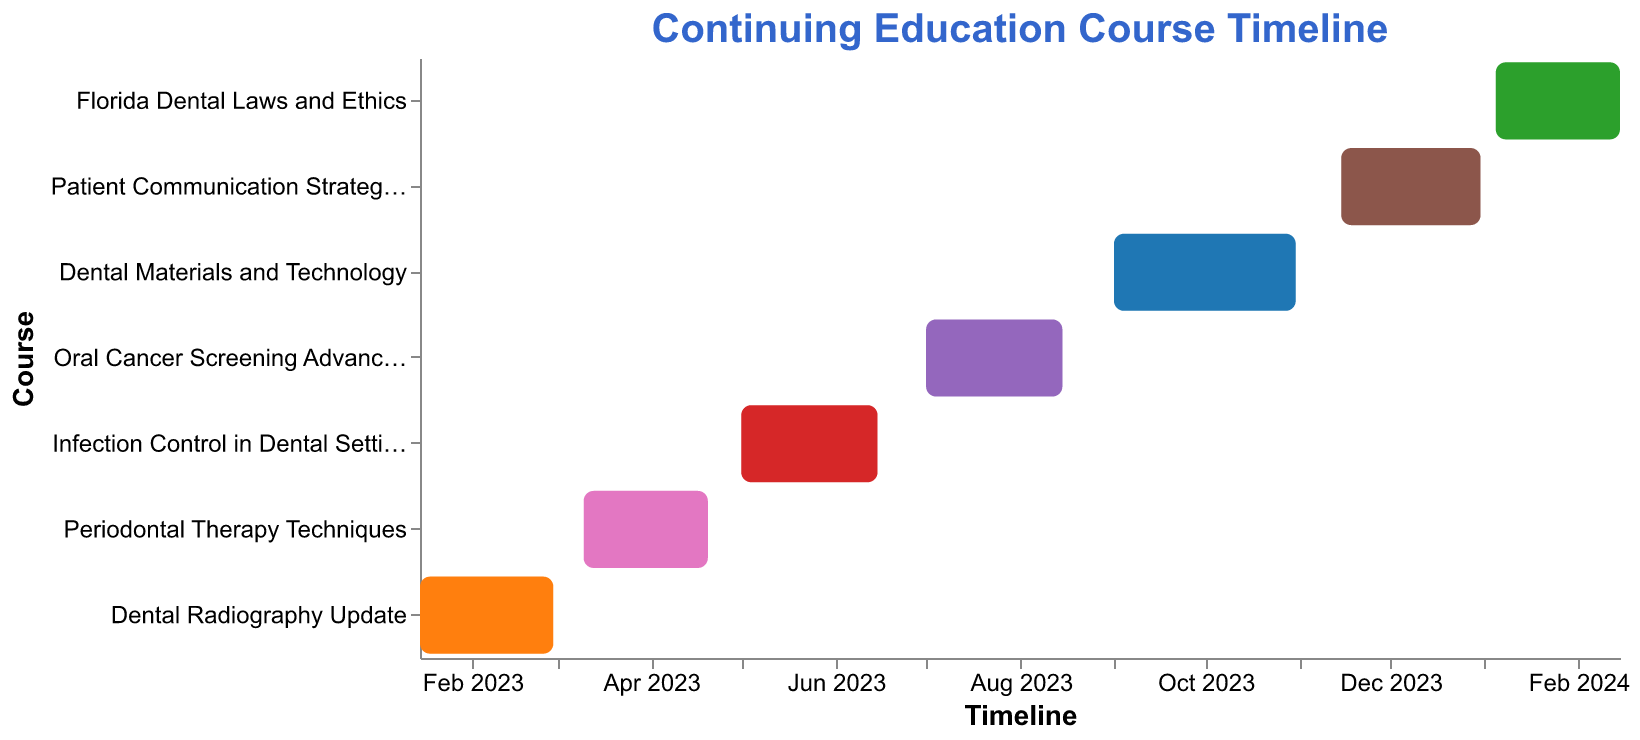How many courses are scheduled for 2023? Look at the timeline on the x-axis and count all the courses that start and end in 2023. There are six courses scheduled for 2023.
Answer: Six When does the "Oral Cancer Screening Advancements" course begin and end? Refer to the location of the bar representing the "Oral Cancer Screening Advancements" course on the Gantt chart to see its start and end dates. It starts on July 1, 2023, and ends on August 15, 2023.
Answer: Starts on July 1, 2023, and ends on August 15, 2023 Which course has the longest duration? Calculate the duration of each course by finding the differences between their start and end dates. The "Dental Materials and Technology" course runs for 61 days (from September 1, 2023, to October 31, 2023).
Answer: Dental Materials and Technology What is the gap between the end of the "Infection Control in Dental Settings" course and the start of the "Oral Cancer Screening Advancements" course? The "Infection Control in Dental Settings" ends on June 15, 2023, and the "Oral Cancer Screening Advancements" begins on July 1, 2023. The gap is 16 days.
Answer: 16 days Which courses run simultaneously for at least part of their duration? Examine the Gantt chart to see overlapping bars, indicating simultaneous courses. "Infection Control in Dental Settings" (May 1, 2023, to June 15, 2023) and "Periodontal Therapy Techniques" (March 10, 2023, to April 20, 2023) overlap for May and June 2023.
Answer: Infection Control in Dental Settings and Periodontal Therapy Techniques What is the total time span covered by all the courses in the timeline? The first course begins on January 15, 2023, and the last course ends on February 15, 2024. The total timespan is from January 15, 2023, to February 15, 2024, covering 1 year and 1 month (13 months).
Answer: 13 months Which course is the last one scheduled to start in 2023? Check the timeline to see which course starts closest to the end of 2023. "Patient Communication Strategies" starts on November 15, 2023.
Answer: Patient Communication Strategies How many courses are ongoing in July 2023? Examine the timeline and look for bars that include July 2023. Two courses, "Oral Cancer Screening Advancements" and "Infection Control in Dental Settings," are ongoing in July 2023.
Answer: Two Compare the duration of the "Periodontal Therapy Techniques" course with the "Patient Communication Strategies" course. Which one is longer? Calculate the duration of both courses by measuring the time from start to end. "Periodontal Therapy Techniques" runs from March 10, 2023, to April 20, 2023 (41 days), while "Patient Communication Strategies" runs from November 15, 2023, to December 31, 2023 (46 days).
Answer: Patient Communication Strategies 